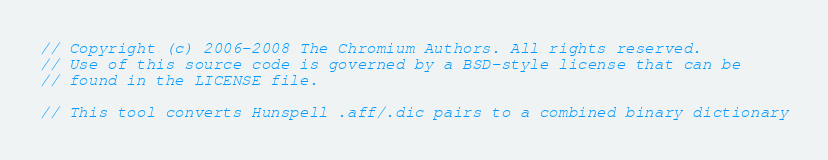<code> <loc_0><loc_0><loc_500><loc_500><_C++_>// Copyright (c) 2006-2008 The Chromium Authors. All rights reserved.
// Use of this source code is governed by a BSD-style license that can be
// found in the LICENSE file.

// This tool converts Hunspell .aff/.dic pairs to a combined binary dictionary</code> 